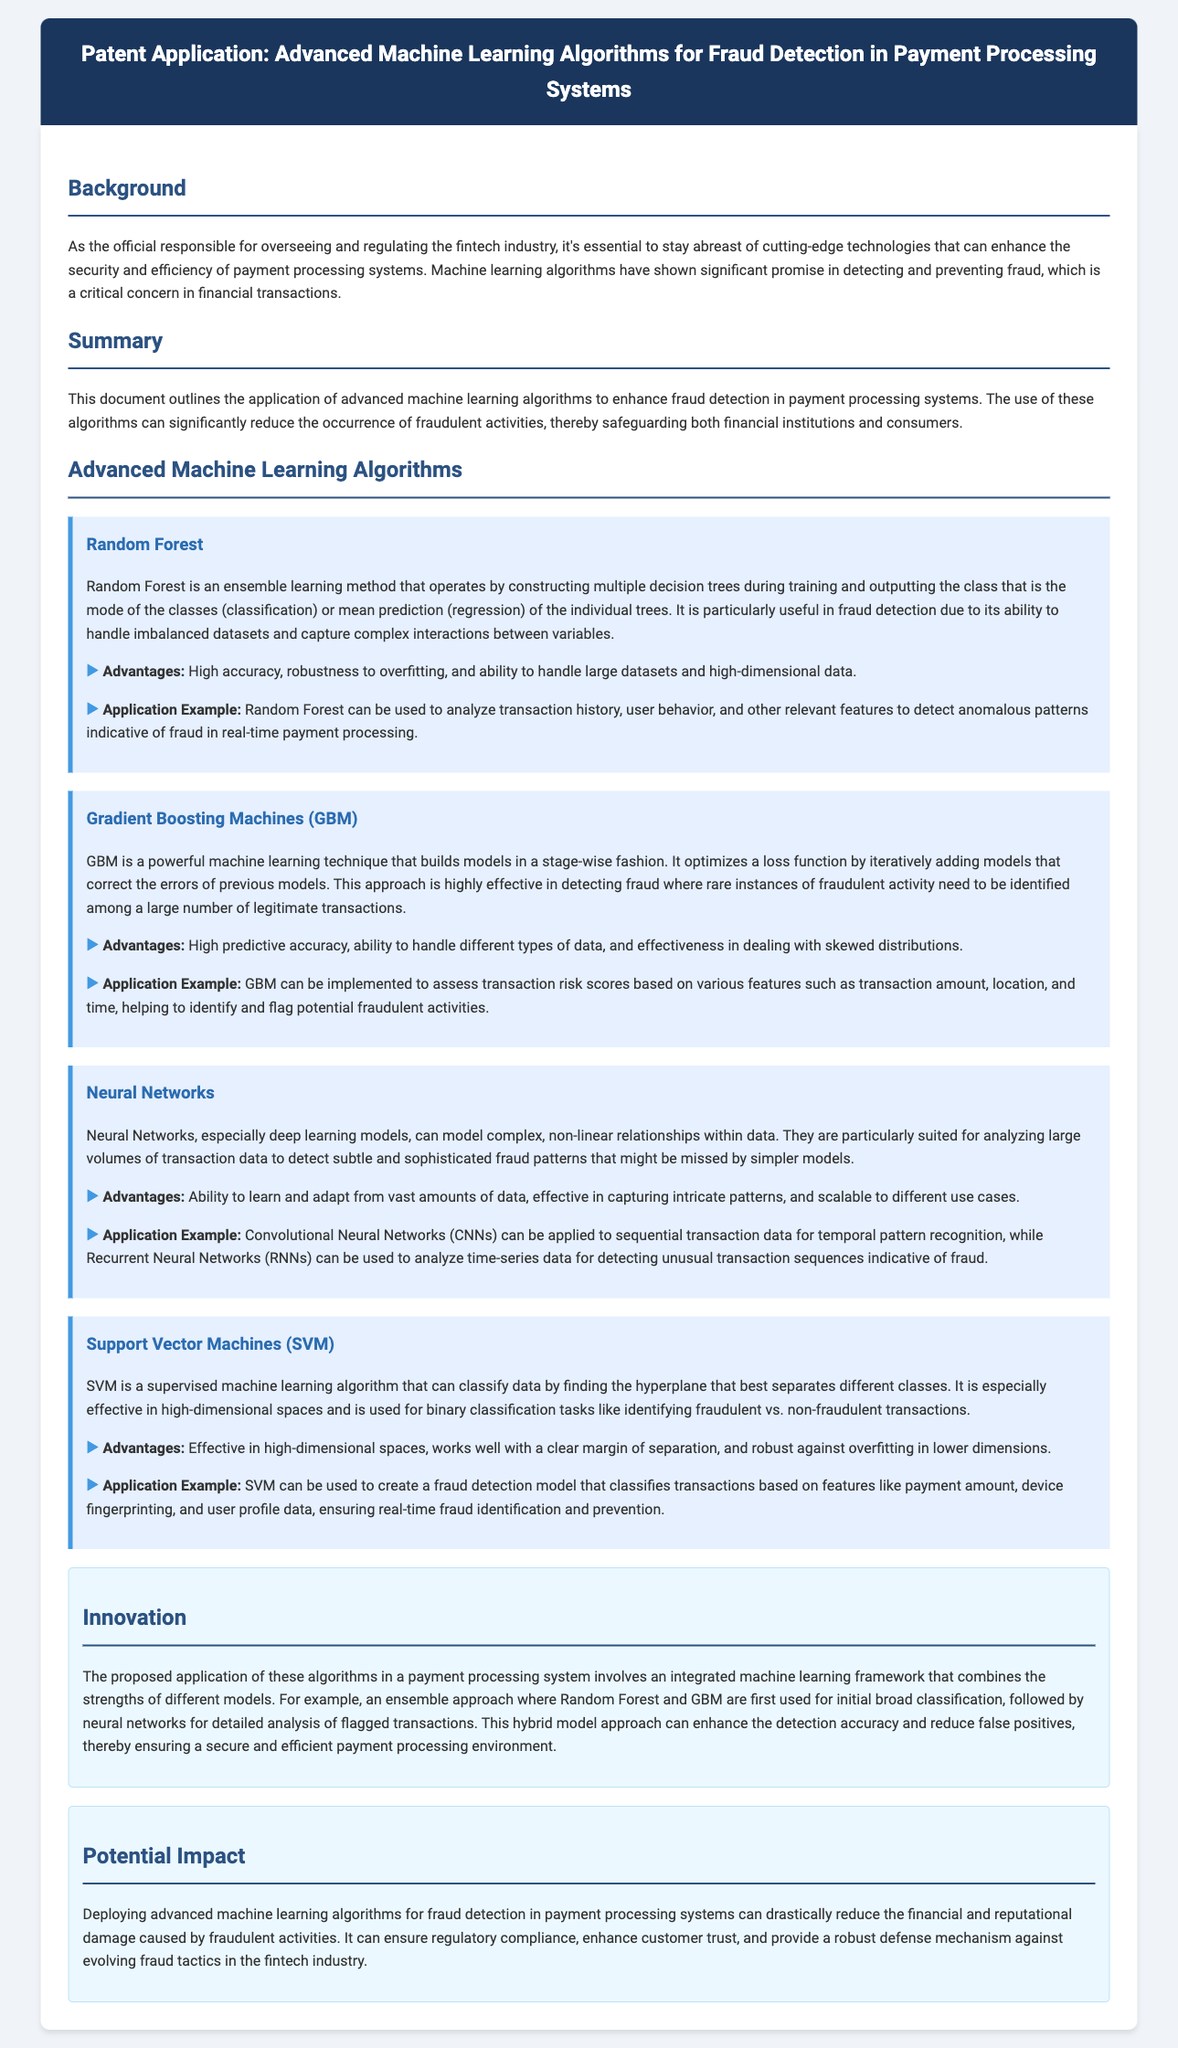What is the title of the patent application? The title of the patent application is the main heading mentioned at the top of the document.
Answer: Advanced Machine Learning Algorithms for Fraud Detection in Payment Processing Systems What is the primary purpose of the advanced machine learning algorithms discussed in the document? The primary purpose is outlined in the summary section, focusing on fraud detection in payment processing systems.
Answer: Enhance fraud detection Which machine learning algorithm is described as an ensemble learning method? This refers to a specific type of algorithm mentioned in the document that builds multiple models.
Answer: Random Forest What is one advantage of using Gradient Boosting Machines? The advantages are listed under the respective algorithm's section, highlighting one distinct benefit.
Answer: High predictive accuracy What does the proposed integrated machine learning framework aim to improve? This is stated in the innovation section where the goals of the framework are discussed.
Answer: Detection accuracy How can Support Vector Machines help in fraud detection? This describes the functionality of this algorithm as mentioned in its application example.
Answer: Classifies transactions What is one potential impact of deploying these algorithms in payment processing systems? The impact is highlighted in the section dedicated to potential outcomes of the technology's application.
Answer: Reduce financial damage Which neural network type is suitable for sequential transaction data analysis? This is specified in the application example of the neural networks section, focusing on a particular deep learning model.
Answer: Convolutional Neural Networks What approach does the innovation section suggest for fraud detection? This describes the methodology of combining several models for enhanced performance in fraud detection.
Answer: Hybrid model approach 